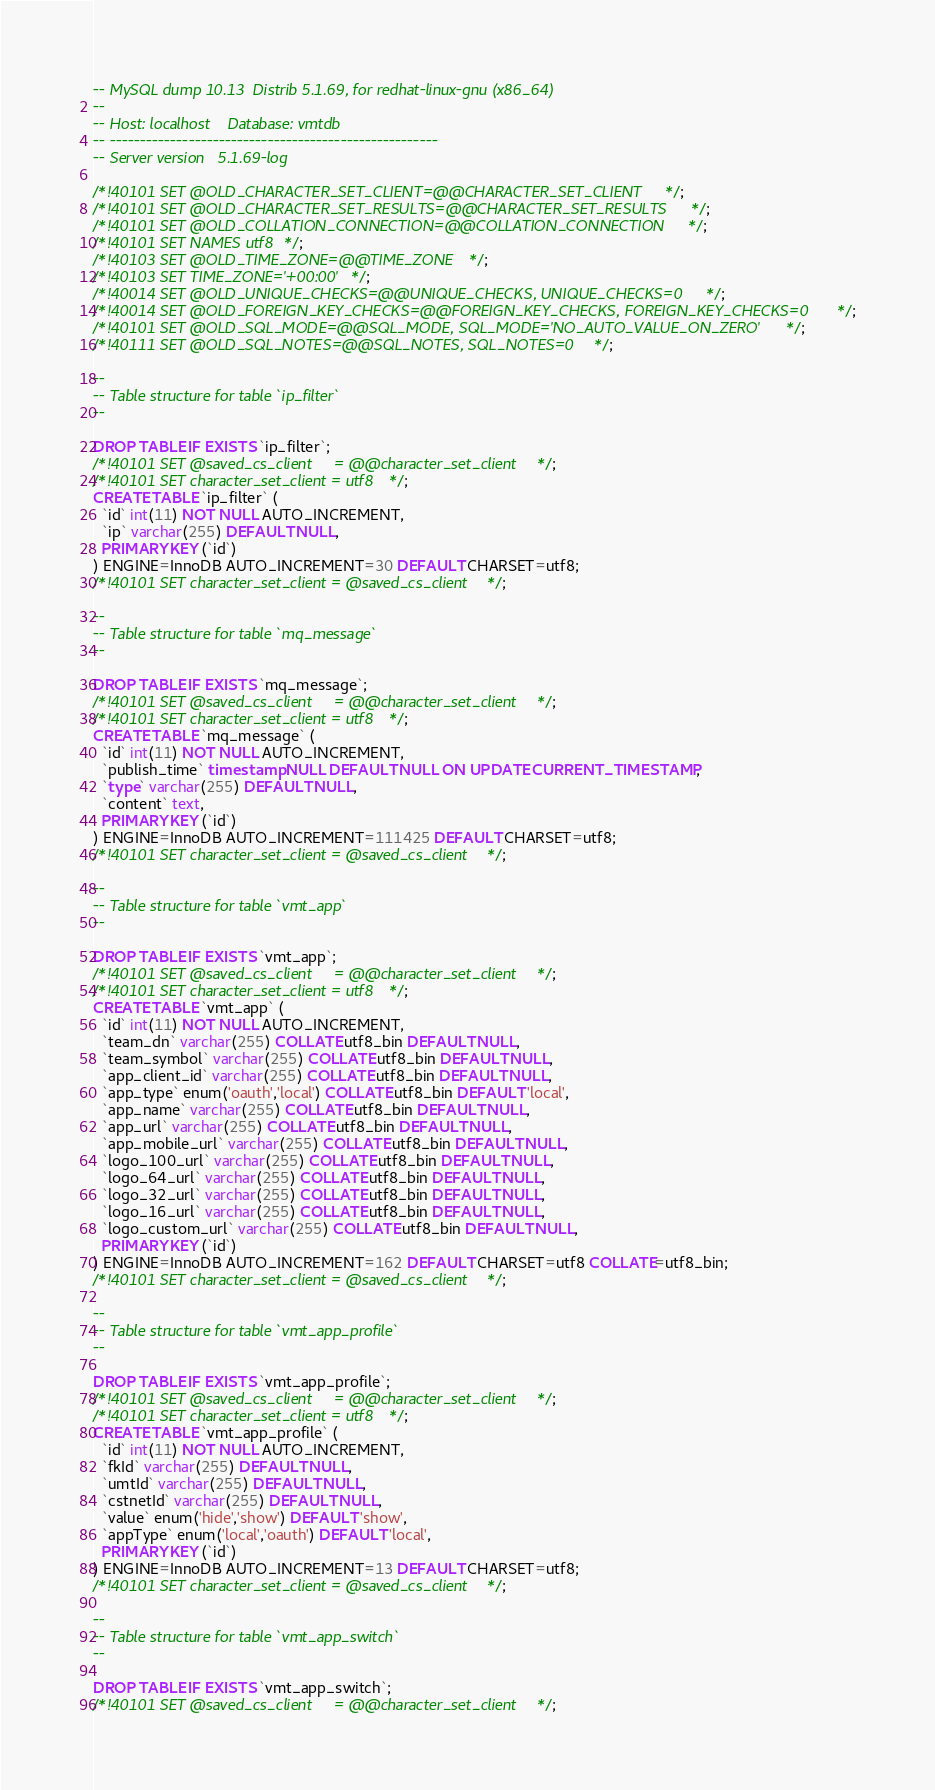Convert code to text. <code><loc_0><loc_0><loc_500><loc_500><_SQL_>-- MySQL dump 10.13  Distrib 5.1.69, for redhat-linux-gnu (x86_64)
--
-- Host: localhost    Database: vmtdb
-- ------------------------------------------------------
-- Server version	5.1.69-log

/*!40101 SET @OLD_CHARACTER_SET_CLIENT=@@CHARACTER_SET_CLIENT */;
/*!40101 SET @OLD_CHARACTER_SET_RESULTS=@@CHARACTER_SET_RESULTS */;
/*!40101 SET @OLD_COLLATION_CONNECTION=@@COLLATION_CONNECTION */;
/*!40101 SET NAMES utf8 */;
/*!40103 SET @OLD_TIME_ZONE=@@TIME_ZONE */;
/*!40103 SET TIME_ZONE='+00:00' */;
/*!40014 SET @OLD_UNIQUE_CHECKS=@@UNIQUE_CHECKS, UNIQUE_CHECKS=0 */;
/*!40014 SET @OLD_FOREIGN_KEY_CHECKS=@@FOREIGN_KEY_CHECKS, FOREIGN_KEY_CHECKS=0 */;
/*!40101 SET @OLD_SQL_MODE=@@SQL_MODE, SQL_MODE='NO_AUTO_VALUE_ON_ZERO' */;
/*!40111 SET @OLD_SQL_NOTES=@@SQL_NOTES, SQL_NOTES=0 */;

--
-- Table structure for table `ip_filter`
--

DROP TABLE IF EXISTS `ip_filter`;
/*!40101 SET @saved_cs_client     = @@character_set_client */;
/*!40101 SET character_set_client = utf8 */;
CREATE TABLE `ip_filter` (
  `id` int(11) NOT NULL AUTO_INCREMENT,
  `ip` varchar(255) DEFAULT NULL,
  PRIMARY KEY (`id`)
) ENGINE=InnoDB AUTO_INCREMENT=30 DEFAULT CHARSET=utf8;
/*!40101 SET character_set_client = @saved_cs_client */;

--
-- Table structure for table `mq_message`
--

DROP TABLE IF EXISTS `mq_message`;
/*!40101 SET @saved_cs_client     = @@character_set_client */;
/*!40101 SET character_set_client = utf8 */;
CREATE TABLE `mq_message` (
  `id` int(11) NOT NULL AUTO_INCREMENT,
  `publish_time` timestamp NULL DEFAULT NULL ON UPDATE CURRENT_TIMESTAMP,
  `type` varchar(255) DEFAULT NULL,
  `content` text,
  PRIMARY KEY (`id`)
) ENGINE=InnoDB AUTO_INCREMENT=111425 DEFAULT CHARSET=utf8;
/*!40101 SET character_set_client = @saved_cs_client */;

--
-- Table structure for table `vmt_app`
--

DROP TABLE IF EXISTS `vmt_app`;
/*!40101 SET @saved_cs_client     = @@character_set_client */;
/*!40101 SET character_set_client = utf8 */;
CREATE TABLE `vmt_app` (
  `id` int(11) NOT NULL AUTO_INCREMENT,
  `team_dn` varchar(255) COLLATE utf8_bin DEFAULT NULL,
  `team_symbol` varchar(255) COLLATE utf8_bin DEFAULT NULL,
  `app_client_id` varchar(255) COLLATE utf8_bin DEFAULT NULL,
  `app_type` enum('oauth','local') COLLATE utf8_bin DEFAULT 'local',
  `app_name` varchar(255) COLLATE utf8_bin DEFAULT NULL,
  `app_url` varchar(255) COLLATE utf8_bin DEFAULT NULL,
  `app_mobile_url` varchar(255) COLLATE utf8_bin DEFAULT NULL,
  `logo_100_url` varchar(255) COLLATE utf8_bin DEFAULT NULL,
  `logo_64_url` varchar(255) COLLATE utf8_bin DEFAULT NULL,
  `logo_32_url` varchar(255) COLLATE utf8_bin DEFAULT NULL,
  `logo_16_url` varchar(255) COLLATE utf8_bin DEFAULT NULL,
  `logo_custom_url` varchar(255) COLLATE utf8_bin DEFAULT NULL,
  PRIMARY KEY (`id`)
) ENGINE=InnoDB AUTO_INCREMENT=162 DEFAULT CHARSET=utf8 COLLATE=utf8_bin;
/*!40101 SET character_set_client = @saved_cs_client */;

--
-- Table structure for table `vmt_app_profile`
--

DROP TABLE IF EXISTS `vmt_app_profile`;
/*!40101 SET @saved_cs_client     = @@character_set_client */;
/*!40101 SET character_set_client = utf8 */;
CREATE TABLE `vmt_app_profile` (
  `id` int(11) NOT NULL AUTO_INCREMENT,
  `fkId` varchar(255) DEFAULT NULL,
  `umtId` varchar(255) DEFAULT NULL,
  `cstnetId` varchar(255) DEFAULT NULL,
  `value` enum('hide','show') DEFAULT 'show',
  `appType` enum('local','oauth') DEFAULT 'local',
  PRIMARY KEY (`id`)
) ENGINE=InnoDB AUTO_INCREMENT=13 DEFAULT CHARSET=utf8;
/*!40101 SET character_set_client = @saved_cs_client */;

--
-- Table structure for table `vmt_app_switch`
--

DROP TABLE IF EXISTS `vmt_app_switch`;
/*!40101 SET @saved_cs_client     = @@character_set_client */;</code> 